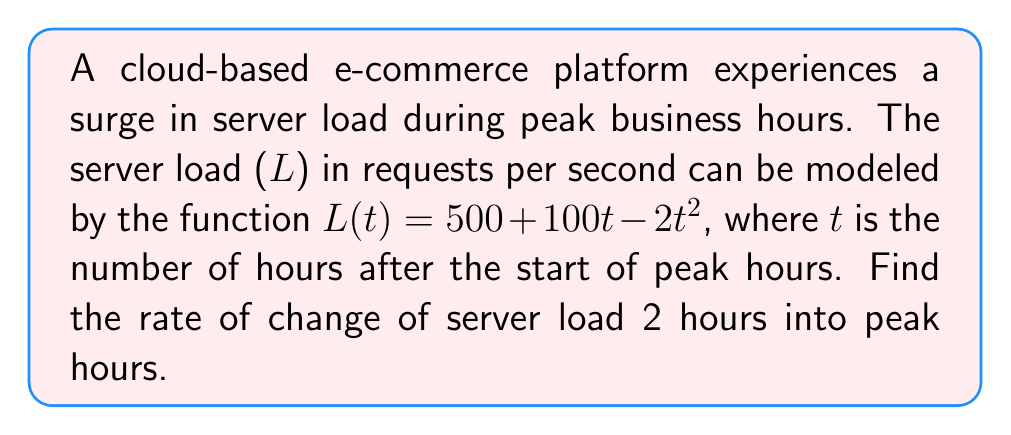Can you answer this question? To find the rate of change of server load at a specific time, we need to calculate the derivative of the given function and evaluate it at the given time.

1. Given function: $L(t) = 500 + 100t - 2t^2$

2. Calculate the derivative:
   $$\frac{dL}{dt} = \frac{d}{dt}(500 + 100t - 2t^2)$$
   $$\frac{dL}{dt} = 0 + 100 - 4t$$
   $$\frac{dL}{dt} = 100 - 4t$$

3. Evaluate the derivative at t = 2 hours:
   $$\frac{dL}{dt}|_{t=2} = 100 - 4(2)$$
   $$\frac{dL}{dt}|_{t=2} = 100 - 8$$
   $$\frac{dL}{dt}|_{t=2} = 92$$

The rate of change of server load 2 hours into peak hours is 92 requests per second per hour.
Answer: 92 requests/second/hour 